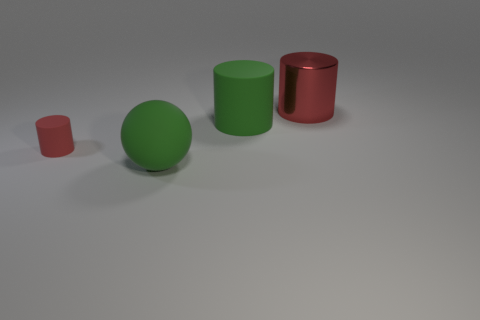There is another thing that is the same color as the shiny thing; what is it made of?
Ensure brevity in your answer.  Rubber. There is a green cylinder that is the same size as the green ball; what is its material?
Offer a very short reply. Rubber. Are there any cyan rubber cylinders of the same size as the green cylinder?
Provide a succinct answer. No. The large rubber cylinder is what color?
Your response must be concise. Green. What color is the large matte cylinder on the left side of the red cylinder on the right side of the tiny red rubber thing?
Provide a succinct answer. Green. There is a red object that is in front of the red cylinder that is on the right side of the red object to the left of the big red metallic thing; what is its shape?
Ensure brevity in your answer.  Cylinder. What number of small cylinders are made of the same material as the sphere?
Your response must be concise. 1. There is a big cylinder to the right of the big green cylinder; what number of red things are to the right of it?
Offer a very short reply. 0. What number of green matte spheres are there?
Ensure brevity in your answer.  1. Is the material of the large green cylinder the same as the red object to the left of the large red metallic thing?
Provide a succinct answer. Yes. 